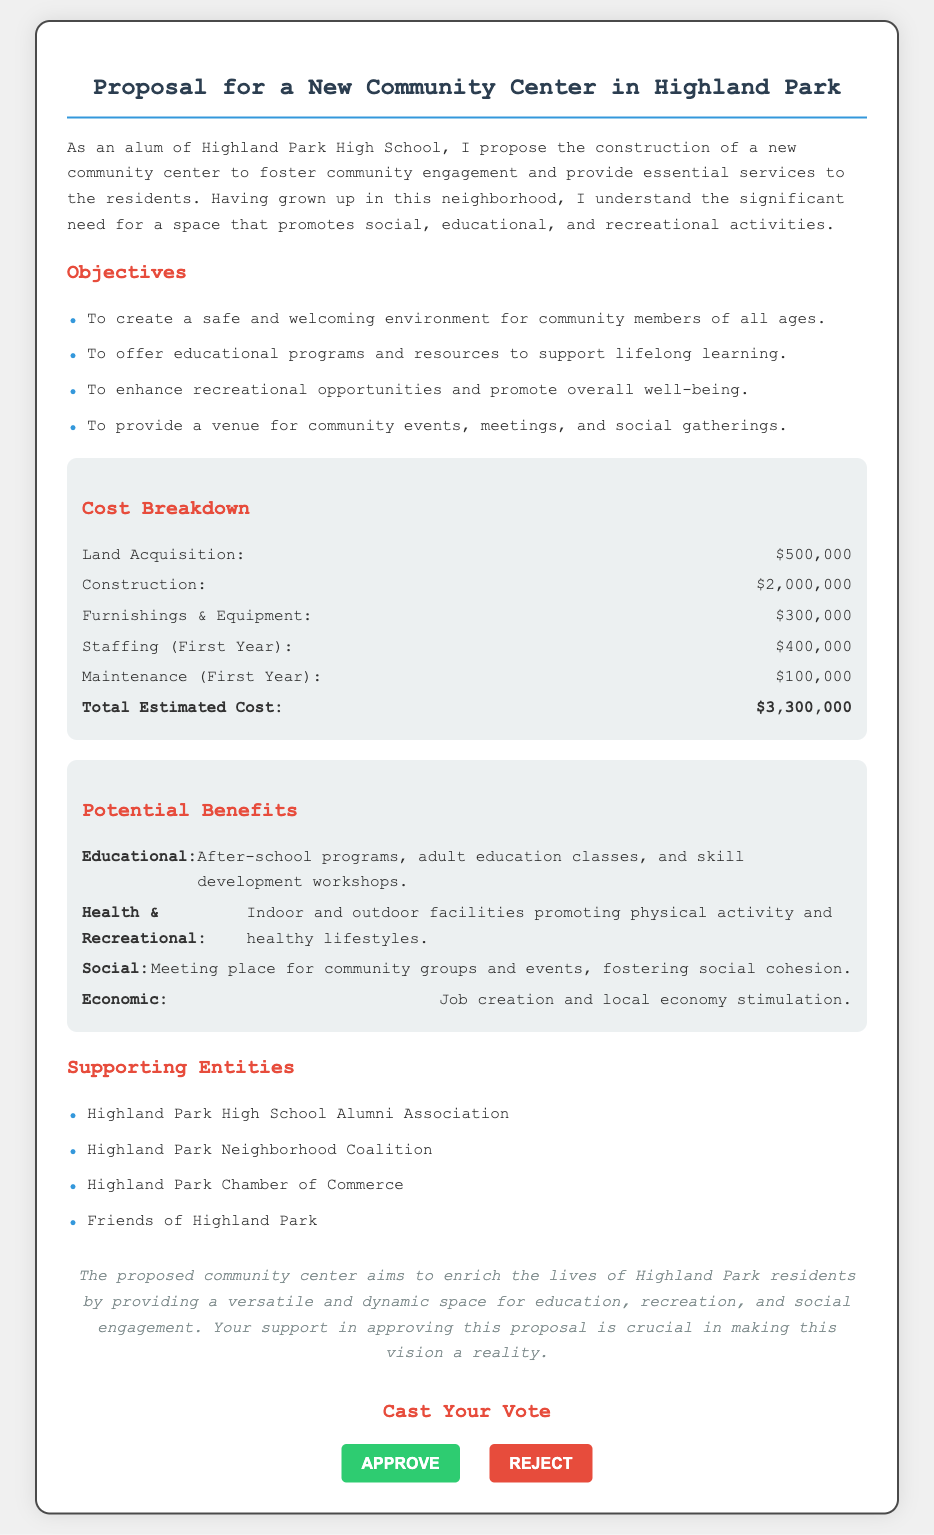What is the total estimated cost? The total estimated cost is listed in the cost breakdown section of the document as $3,300,000.
Answer: $3,300,000 What is the amount allocated for land acquisition? The cost breakdown specifies the amount for land acquisition, which is $500,000.
Answer: $500,000 What type of programs will be offered according to the potential benefits? The potential benefits mention several types of programs, including after-school programs and adult education classes.
Answer: Educational programs Which organization is listed as a supporting entity? The document includes several supporting entities, one of which is the Highland Park Chamber of Commerce.
Answer: Highland Park Chamber of Commerce What is one of the social benefits mentioned? The document states that one of the social benefits is to provide a meeting place for community groups and events.
Answer: Meeting place How much is allocated for staffing in the first year? The cost breakdown details that the amount allocated for staffing in the first year is $400,000.
Answer: $400,000 What is the purpose of the proposed community center? The main purpose, as outlined in the document, is to foster community engagement and provide essential services to residents.
Answer: Foster community engagement What is one health benefit of the community center? The potential benefits section highlights that there will be indoor and outdoor facilities promoting physical activity and healthy lifestyles.
Answer: Physical activity What is an objective of the proposal? The objectives listed in the document include creating a safe and welcoming environment.
Answer: Safe and welcoming environment 